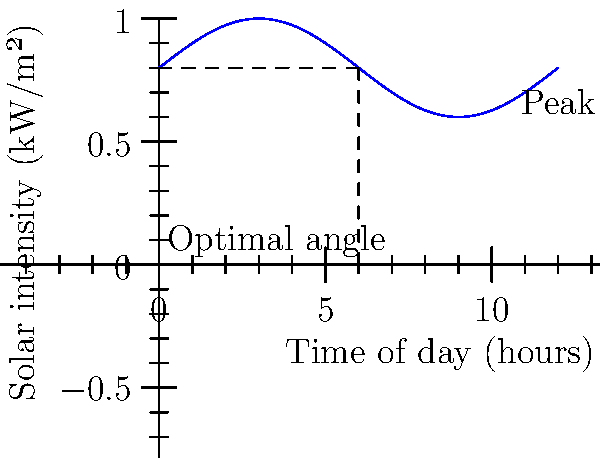As a real estate developer planning to integrate solar panels into your Boke area revitalization project, you're analyzing solar intensity data for optimal panel placement. The graph shows solar intensity throughout the day. If you can only adjust the panels once per day, at what angle (in degrees) should you set them to maximize energy collection, assuming the sun's position changes by 15° per hour? To determine the optimal angle for solar panel placement:

1. Identify the peak solar intensity from the graph, which occurs at 6 hours (noon).

2. Calculate the sun's position at noon:
   - The sun moves 15° per hour
   - At 6 hours (noon), the sun's position is: $6 \times 15° = 90°$ from the horizon

3. For maximum energy collection, solar panels should be perpendicular to incoming sunlight.

4. The optimal angle for the panels is the complement of the sun's position:
   $\text{Optimal Angle} = 90° - \text{Sun's Position}$
   $\text{Optimal Angle} = 90° - 90° = 0°$

5. This means the panels should be positioned horizontally (flat) to be perpendicular to the sun at its peak intensity.

This approach ensures maximum energy collection during peak solar intensity, which is crucial for optimizing the efficiency of solar installations in your development project.
Answer: 0° 